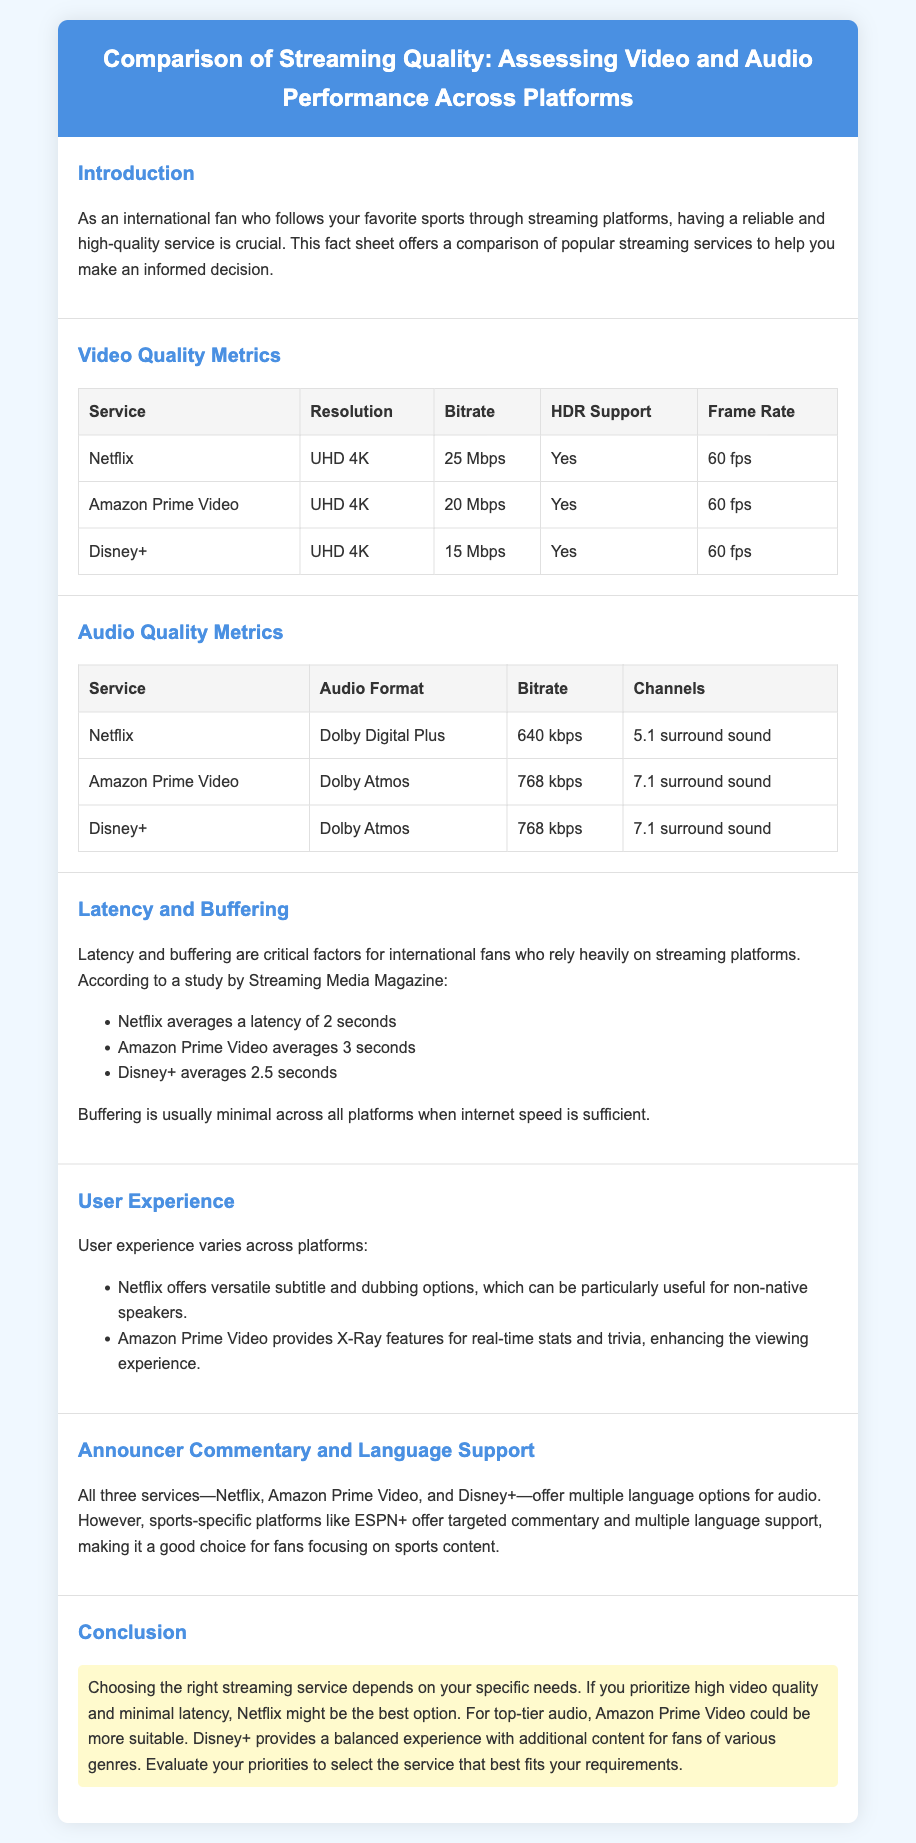what is the highest video bitrate for Amazon Prime Video? The table in the Video Quality Metrics section indicates that Amazon Prime Video has a bitrate of 20 Mbps.
Answer: 20 Mbps which audio format does Netflix use? The Audio Quality Metrics table shows that Netflix uses Dolby Digital Plus as its audio format.
Answer: Dolby Digital Plus what is the average latency for Disney+? The document states that Disney+ averages a latency of 2.5 seconds.
Answer: 2.5 seconds which service provides Dolby Atmos audio? The Audio Quality Metrics section reveals that both Amazon Prime Video and Disney+ provide Dolby Atmos audio.
Answer: Amazon Prime Video, Disney+ what user experience feature does Amazon Prime Video offer? The document mentions that Amazon Prime Video provides X-Ray features for real-time stats and trivia to enhance the viewing experience.
Answer: X-Ray features which streaming service offers the best video quality based on the document? The conclusion indicates that Netflix might be the best option for high video quality and minimal latency.
Answer: Netflix what is the resolution provided by Disney+? According to the Video Quality Metrics table, Disney+ offers UHD 4K resolution.
Answer: UHD 4K how many channels does Amazon Prime Video's audio support? The Audio Quality Metrics section shows that Amazon Prime Video supports 7.1 surround sound channels.
Answer: 7.1 surround sound 